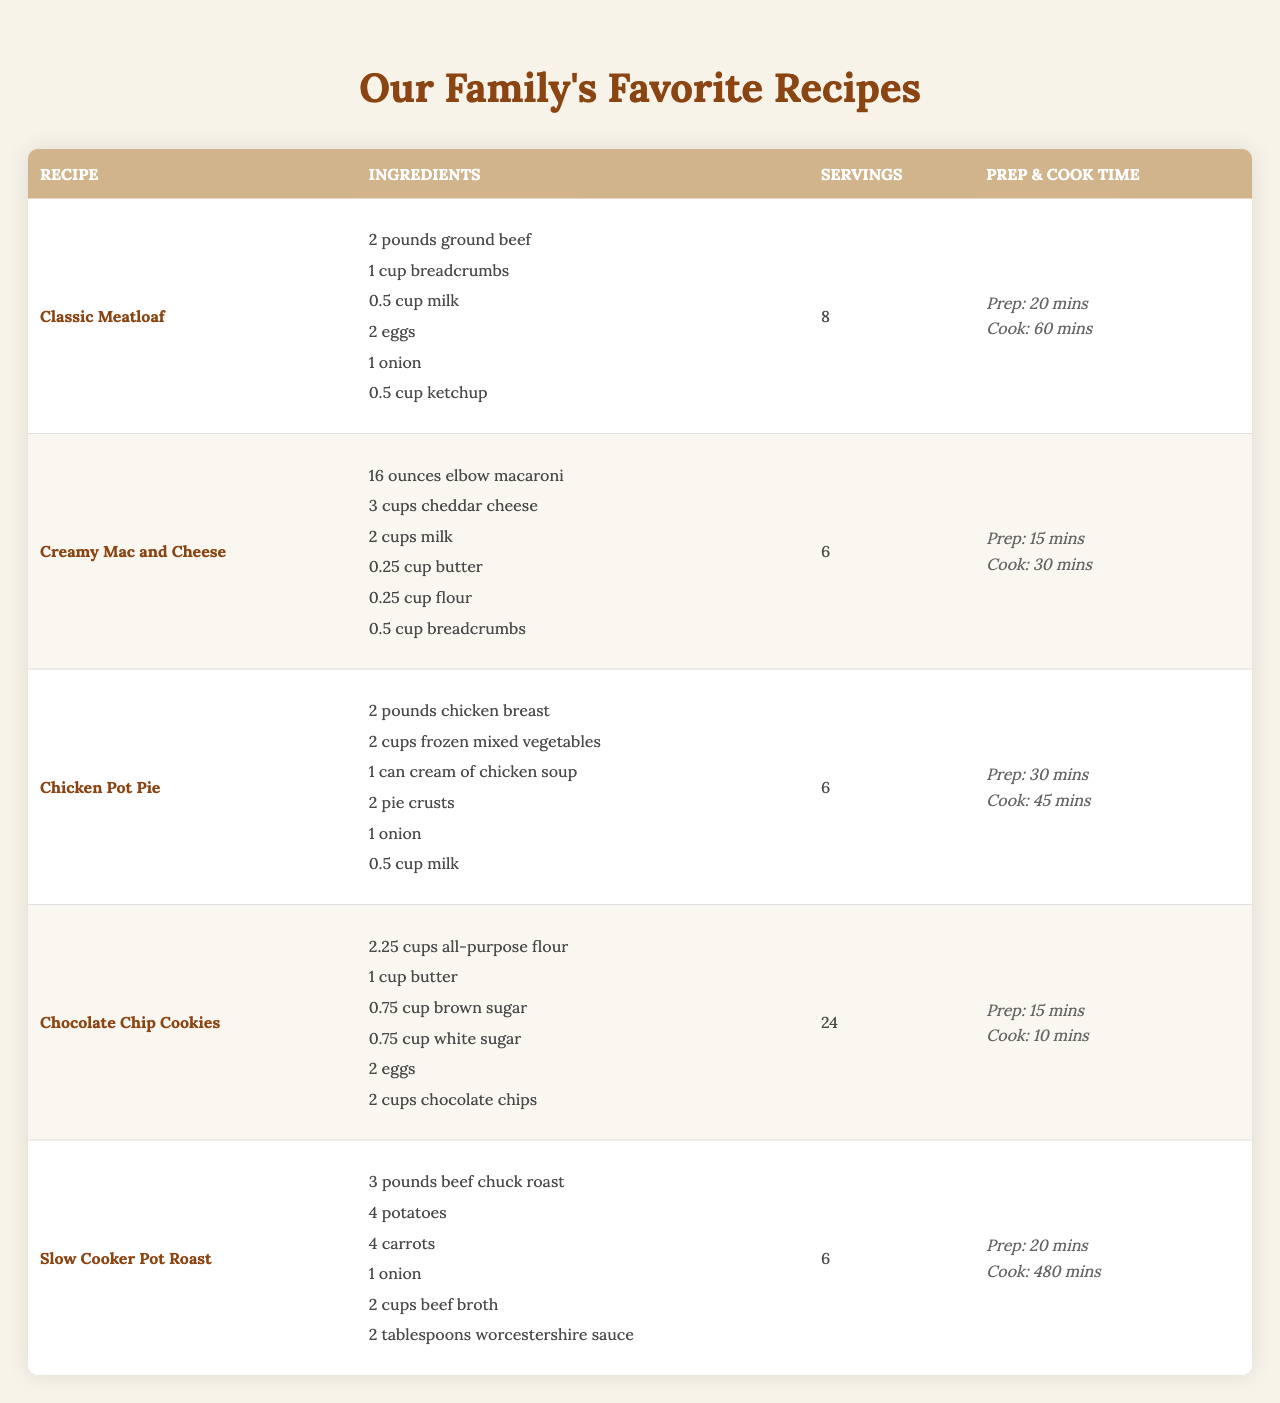What is the total cooking time for the Chocolate Chip Cookies? The cooking time listed for the Chocolate Chip Cookies is 10 minutes. Since there are no additional steps indicated that would add to this time, the total cooking time remains 10 minutes.
Answer: 10 minutes How many servings does the Classic Meatloaf recipe make? The table indicates that the Classic Meatloaf recipe serves 8 people. Therefore, the answer is simply retrieved from the table.
Answer: 8 servings Which recipe has the least prep time? Reviewing the prep times in the table shows that the Chocolate Chip Cookies have a prep time of 15 minutes, which is the shortest listed compared to the other recipes.
Answer: 15 minutes How many cups of milk are needed for the Creamy Mac and Cheese? According to the table, the Creamy Mac and Cheese requires 2 cups of milk, which is stated directly in the ingredients list.
Answer: 2 cups What is the total amount of ground beef and chicken used in the recipes? The Classic Meatloaf uses 2 pounds of ground beef and the Chicken Pot Pie uses 2 pounds of chicken breast. Summing these amounts results in 2 + 2 = 4 pounds.
Answer: 4 pounds True or False: The Slow Cooker Pot Roast recipe includes carrots as an ingredient. The table lists carrots as one of the ingredients for the Slow Cooker Pot Roast. Therefore, the statement is true.
Answer: True How many more servings does the Slow Cooker Pot Roast provide compared to the Chicken Pot Pie? The Slow Cooker Pot Roast serves 6 people, and the Chicken Pot Pie also serves 6 people. The difference is 6 - 6 = 0, indicating they provide an equal number of servings.
Answer: 0 servings If I want to prepare all the recipes, how many total cups of cheese will I need? The only recipe that includes cheese is the Creamy Mac and Cheese, which calls for 3 cups of cheddar cheese. Since it's the only cheese listed, the total is simply 3 cups.
Answer: 3 cups What is the average prep time of all recipes listed in the table? The prep times are 20, 15, 30, 15, and 20 minutes. Summing these gives a total of 100 minutes for 5 recipes. The average is therefore 100 minutes / 5 = 20 minutes.
Answer: 20 minutes Which recipe has the longest cook time and what is that time? The Slow Cooker Pot Roast has a cook time of 480 minutes, the longest among all recipes. Other recipes have shorter cooking times, confirming that this is the longest.
Answer: 480 minutes 